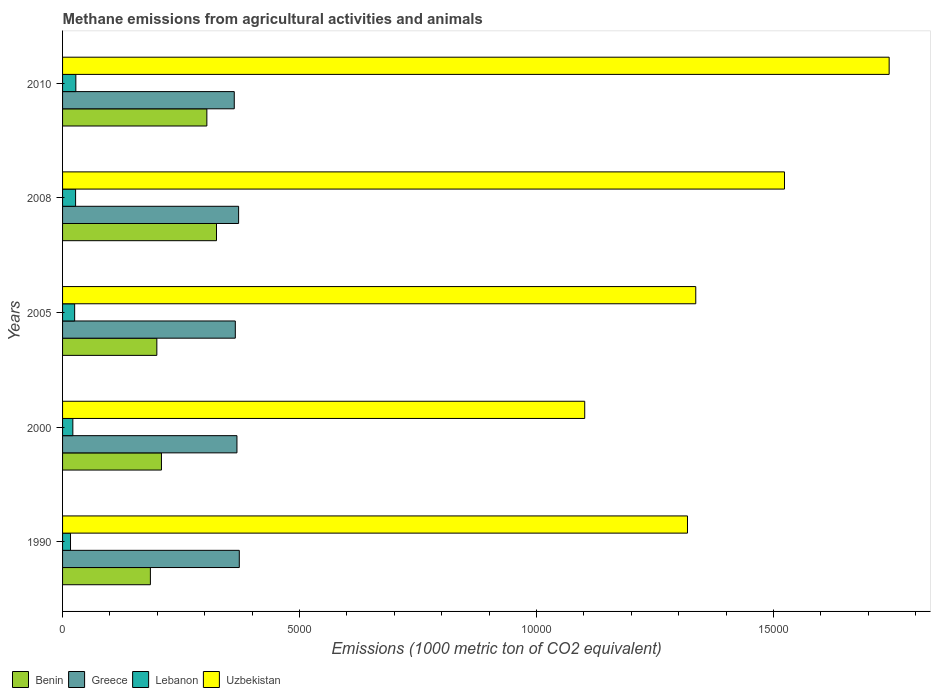How many groups of bars are there?
Give a very brief answer. 5. Are the number of bars per tick equal to the number of legend labels?
Your response must be concise. Yes. What is the label of the 2nd group of bars from the top?
Offer a terse response. 2008. What is the amount of methane emitted in Lebanon in 2000?
Make the answer very short. 216.7. Across all years, what is the maximum amount of methane emitted in Greece?
Your response must be concise. 3728.5. Across all years, what is the minimum amount of methane emitted in Lebanon?
Offer a terse response. 167.6. In which year was the amount of methane emitted in Uzbekistan maximum?
Ensure brevity in your answer.  2010. In which year was the amount of methane emitted in Uzbekistan minimum?
Your answer should be very brief. 2000. What is the total amount of methane emitted in Uzbekistan in the graph?
Your answer should be very brief. 7.02e+04. What is the difference between the amount of methane emitted in Benin in 2005 and that in 2008?
Your answer should be compact. -1258.4. What is the difference between the amount of methane emitted in Uzbekistan in 1990 and the amount of methane emitted in Greece in 2005?
Keep it short and to the point. 9539.8. What is the average amount of methane emitted in Benin per year?
Make the answer very short. 2444.08. In the year 2010, what is the difference between the amount of methane emitted in Greece and amount of methane emitted in Lebanon?
Provide a succinct answer. 3342.4. What is the ratio of the amount of methane emitted in Lebanon in 2008 to that in 2010?
Provide a short and direct response. 0.98. Is the difference between the amount of methane emitted in Greece in 1990 and 2010 greater than the difference between the amount of methane emitted in Lebanon in 1990 and 2010?
Your answer should be very brief. Yes. What is the difference between the highest and the second highest amount of methane emitted in Benin?
Your response must be concise. 203.3. What is the difference between the highest and the lowest amount of methane emitted in Benin?
Offer a very short reply. 1394.6. In how many years, is the amount of methane emitted in Lebanon greater than the average amount of methane emitted in Lebanon taken over all years?
Offer a terse response. 3. Is the sum of the amount of methane emitted in Benin in 2005 and 2010 greater than the maximum amount of methane emitted in Uzbekistan across all years?
Give a very brief answer. No. What does the 1st bar from the bottom in 2008 represents?
Provide a succinct answer. Benin. How many bars are there?
Ensure brevity in your answer.  20. Are all the bars in the graph horizontal?
Provide a short and direct response. Yes. How many years are there in the graph?
Offer a terse response. 5. What is the difference between two consecutive major ticks on the X-axis?
Offer a very short reply. 5000. Are the values on the major ticks of X-axis written in scientific E-notation?
Make the answer very short. No. Does the graph contain any zero values?
Your response must be concise. No. Where does the legend appear in the graph?
Offer a terse response. Bottom left. How many legend labels are there?
Offer a terse response. 4. What is the title of the graph?
Offer a terse response. Methane emissions from agricultural activities and animals. Does "Paraguay" appear as one of the legend labels in the graph?
Your answer should be very brief. No. What is the label or title of the X-axis?
Ensure brevity in your answer.  Emissions (1000 metric ton of CO2 equivalent). What is the label or title of the Y-axis?
Provide a short and direct response. Years. What is the Emissions (1000 metric ton of CO2 equivalent) in Benin in 1990?
Give a very brief answer. 1853. What is the Emissions (1000 metric ton of CO2 equivalent) in Greece in 1990?
Give a very brief answer. 3728.5. What is the Emissions (1000 metric ton of CO2 equivalent) in Lebanon in 1990?
Ensure brevity in your answer.  167.6. What is the Emissions (1000 metric ton of CO2 equivalent) in Uzbekistan in 1990?
Give a very brief answer. 1.32e+04. What is the Emissions (1000 metric ton of CO2 equivalent) of Benin in 2000?
Offer a very short reply. 2086.3. What is the Emissions (1000 metric ton of CO2 equivalent) of Greece in 2000?
Ensure brevity in your answer.  3679.3. What is the Emissions (1000 metric ton of CO2 equivalent) in Lebanon in 2000?
Offer a very short reply. 216.7. What is the Emissions (1000 metric ton of CO2 equivalent) in Uzbekistan in 2000?
Provide a short and direct response. 1.10e+04. What is the Emissions (1000 metric ton of CO2 equivalent) of Benin in 2005?
Offer a terse response. 1989.2. What is the Emissions (1000 metric ton of CO2 equivalent) in Greece in 2005?
Offer a terse response. 3644.6. What is the Emissions (1000 metric ton of CO2 equivalent) in Lebanon in 2005?
Your answer should be very brief. 255.2. What is the Emissions (1000 metric ton of CO2 equivalent) of Uzbekistan in 2005?
Provide a succinct answer. 1.34e+04. What is the Emissions (1000 metric ton of CO2 equivalent) of Benin in 2008?
Keep it short and to the point. 3247.6. What is the Emissions (1000 metric ton of CO2 equivalent) in Greece in 2008?
Make the answer very short. 3714.1. What is the Emissions (1000 metric ton of CO2 equivalent) in Lebanon in 2008?
Offer a very short reply. 275. What is the Emissions (1000 metric ton of CO2 equivalent) in Uzbekistan in 2008?
Keep it short and to the point. 1.52e+04. What is the Emissions (1000 metric ton of CO2 equivalent) in Benin in 2010?
Make the answer very short. 3044.3. What is the Emissions (1000 metric ton of CO2 equivalent) of Greece in 2010?
Give a very brief answer. 3622.4. What is the Emissions (1000 metric ton of CO2 equivalent) of Lebanon in 2010?
Provide a succinct answer. 280. What is the Emissions (1000 metric ton of CO2 equivalent) of Uzbekistan in 2010?
Your answer should be compact. 1.74e+04. Across all years, what is the maximum Emissions (1000 metric ton of CO2 equivalent) of Benin?
Your answer should be very brief. 3247.6. Across all years, what is the maximum Emissions (1000 metric ton of CO2 equivalent) of Greece?
Give a very brief answer. 3728.5. Across all years, what is the maximum Emissions (1000 metric ton of CO2 equivalent) in Lebanon?
Provide a short and direct response. 280. Across all years, what is the maximum Emissions (1000 metric ton of CO2 equivalent) of Uzbekistan?
Your response must be concise. 1.74e+04. Across all years, what is the minimum Emissions (1000 metric ton of CO2 equivalent) in Benin?
Your answer should be compact. 1853. Across all years, what is the minimum Emissions (1000 metric ton of CO2 equivalent) of Greece?
Provide a short and direct response. 3622.4. Across all years, what is the minimum Emissions (1000 metric ton of CO2 equivalent) in Lebanon?
Keep it short and to the point. 167.6. Across all years, what is the minimum Emissions (1000 metric ton of CO2 equivalent) in Uzbekistan?
Ensure brevity in your answer.  1.10e+04. What is the total Emissions (1000 metric ton of CO2 equivalent) in Benin in the graph?
Give a very brief answer. 1.22e+04. What is the total Emissions (1000 metric ton of CO2 equivalent) in Greece in the graph?
Offer a very short reply. 1.84e+04. What is the total Emissions (1000 metric ton of CO2 equivalent) of Lebanon in the graph?
Provide a short and direct response. 1194.5. What is the total Emissions (1000 metric ton of CO2 equivalent) in Uzbekistan in the graph?
Your answer should be very brief. 7.02e+04. What is the difference between the Emissions (1000 metric ton of CO2 equivalent) of Benin in 1990 and that in 2000?
Provide a succinct answer. -233.3. What is the difference between the Emissions (1000 metric ton of CO2 equivalent) in Greece in 1990 and that in 2000?
Give a very brief answer. 49.2. What is the difference between the Emissions (1000 metric ton of CO2 equivalent) of Lebanon in 1990 and that in 2000?
Offer a very short reply. -49.1. What is the difference between the Emissions (1000 metric ton of CO2 equivalent) of Uzbekistan in 1990 and that in 2000?
Make the answer very short. 2168. What is the difference between the Emissions (1000 metric ton of CO2 equivalent) in Benin in 1990 and that in 2005?
Make the answer very short. -136.2. What is the difference between the Emissions (1000 metric ton of CO2 equivalent) of Greece in 1990 and that in 2005?
Offer a very short reply. 83.9. What is the difference between the Emissions (1000 metric ton of CO2 equivalent) of Lebanon in 1990 and that in 2005?
Give a very brief answer. -87.6. What is the difference between the Emissions (1000 metric ton of CO2 equivalent) in Uzbekistan in 1990 and that in 2005?
Offer a very short reply. -174.6. What is the difference between the Emissions (1000 metric ton of CO2 equivalent) of Benin in 1990 and that in 2008?
Your answer should be compact. -1394.6. What is the difference between the Emissions (1000 metric ton of CO2 equivalent) in Lebanon in 1990 and that in 2008?
Make the answer very short. -107.4. What is the difference between the Emissions (1000 metric ton of CO2 equivalent) of Uzbekistan in 1990 and that in 2008?
Your answer should be compact. -2046.5. What is the difference between the Emissions (1000 metric ton of CO2 equivalent) of Benin in 1990 and that in 2010?
Offer a very short reply. -1191.3. What is the difference between the Emissions (1000 metric ton of CO2 equivalent) of Greece in 1990 and that in 2010?
Provide a succinct answer. 106.1. What is the difference between the Emissions (1000 metric ton of CO2 equivalent) in Lebanon in 1990 and that in 2010?
Offer a very short reply. -112.4. What is the difference between the Emissions (1000 metric ton of CO2 equivalent) in Uzbekistan in 1990 and that in 2010?
Keep it short and to the point. -4255. What is the difference between the Emissions (1000 metric ton of CO2 equivalent) in Benin in 2000 and that in 2005?
Your answer should be very brief. 97.1. What is the difference between the Emissions (1000 metric ton of CO2 equivalent) in Greece in 2000 and that in 2005?
Your answer should be compact. 34.7. What is the difference between the Emissions (1000 metric ton of CO2 equivalent) in Lebanon in 2000 and that in 2005?
Give a very brief answer. -38.5. What is the difference between the Emissions (1000 metric ton of CO2 equivalent) of Uzbekistan in 2000 and that in 2005?
Offer a very short reply. -2342.6. What is the difference between the Emissions (1000 metric ton of CO2 equivalent) in Benin in 2000 and that in 2008?
Give a very brief answer. -1161.3. What is the difference between the Emissions (1000 metric ton of CO2 equivalent) in Greece in 2000 and that in 2008?
Offer a very short reply. -34.8. What is the difference between the Emissions (1000 metric ton of CO2 equivalent) in Lebanon in 2000 and that in 2008?
Your answer should be very brief. -58.3. What is the difference between the Emissions (1000 metric ton of CO2 equivalent) in Uzbekistan in 2000 and that in 2008?
Provide a succinct answer. -4214.5. What is the difference between the Emissions (1000 metric ton of CO2 equivalent) of Benin in 2000 and that in 2010?
Make the answer very short. -958. What is the difference between the Emissions (1000 metric ton of CO2 equivalent) in Greece in 2000 and that in 2010?
Ensure brevity in your answer.  56.9. What is the difference between the Emissions (1000 metric ton of CO2 equivalent) in Lebanon in 2000 and that in 2010?
Make the answer very short. -63.3. What is the difference between the Emissions (1000 metric ton of CO2 equivalent) of Uzbekistan in 2000 and that in 2010?
Your response must be concise. -6423. What is the difference between the Emissions (1000 metric ton of CO2 equivalent) in Benin in 2005 and that in 2008?
Your answer should be compact. -1258.4. What is the difference between the Emissions (1000 metric ton of CO2 equivalent) of Greece in 2005 and that in 2008?
Provide a succinct answer. -69.5. What is the difference between the Emissions (1000 metric ton of CO2 equivalent) in Lebanon in 2005 and that in 2008?
Keep it short and to the point. -19.8. What is the difference between the Emissions (1000 metric ton of CO2 equivalent) of Uzbekistan in 2005 and that in 2008?
Provide a short and direct response. -1871.9. What is the difference between the Emissions (1000 metric ton of CO2 equivalent) in Benin in 2005 and that in 2010?
Give a very brief answer. -1055.1. What is the difference between the Emissions (1000 metric ton of CO2 equivalent) in Greece in 2005 and that in 2010?
Offer a very short reply. 22.2. What is the difference between the Emissions (1000 metric ton of CO2 equivalent) in Lebanon in 2005 and that in 2010?
Your answer should be compact. -24.8. What is the difference between the Emissions (1000 metric ton of CO2 equivalent) in Uzbekistan in 2005 and that in 2010?
Keep it short and to the point. -4080.4. What is the difference between the Emissions (1000 metric ton of CO2 equivalent) of Benin in 2008 and that in 2010?
Offer a very short reply. 203.3. What is the difference between the Emissions (1000 metric ton of CO2 equivalent) of Greece in 2008 and that in 2010?
Provide a succinct answer. 91.7. What is the difference between the Emissions (1000 metric ton of CO2 equivalent) in Uzbekistan in 2008 and that in 2010?
Keep it short and to the point. -2208.5. What is the difference between the Emissions (1000 metric ton of CO2 equivalent) of Benin in 1990 and the Emissions (1000 metric ton of CO2 equivalent) of Greece in 2000?
Ensure brevity in your answer.  -1826.3. What is the difference between the Emissions (1000 metric ton of CO2 equivalent) in Benin in 1990 and the Emissions (1000 metric ton of CO2 equivalent) in Lebanon in 2000?
Your answer should be compact. 1636.3. What is the difference between the Emissions (1000 metric ton of CO2 equivalent) of Benin in 1990 and the Emissions (1000 metric ton of CO2 equivalent) of Uzbekistan in 2000?
Provide a succinct answer. -9163.4. What is the difference between the Emissions (1000 metric ton of CO2 equivalent) in Greece in 1990 and the Emissions (1000 metric ton of CO2 equivalent) in Lebanon in 2000?
Give a very brief answer. 3511.8. What is the difference between the Emissions (1000 metric ton of CO2 equivalent) in Greece in 1990 and the Emissions (1000 metric ton of CO2 equivalent) in Uzbekistan in 2000?
Your answer should be very brief. -7287.9. What is the difference between the Emissions (1000 metric ton of CO2 equivalent) in Lebanon in 1990 and the Emissions (1000 metric ton of CO2 equivalent) in Uzbekistan in 2000?
Provide a succinct answer. -1.08e+04. What is the difference between the Emissions (1000 metric ton of CO2 equivalent) in Benin in 1990 and the Emissions (1000 metric ton of CO2 equivalent) in Greece in 2005?
Your answer should be very brief. -1791.6. What is the difference between the Emissions (1000 metric ton of CO2 equivalent) in Benin in 1990 and the Emissions (1000 metric ton of CO2 equivalent) in Lebanon in 2005?
Your answer should be very brief. 1597.8. What is the difference between the Emissions (1000 metric ton of CO2 equivalent) of Benin in 1990 and the Emissions (1000 metric ton of CO2 equivalent) of Uzbekistan in 2005?
Your answer should be very brief. -1.15e+04. What is the difference between the Emissions (1000 metric ton of CO2 equivalent) in Greece in 1990 and the Emissions (1000 metric ton of CO2 equivalent) in Lebanon in 2005?
Give a very brief answer. 3473.3. What is the difference between the Emissions (1000 metric ton of CO2 equivalent) in Greece in 1990 and the Emissions (1000 metric ton of CO2 equivalent) in Uzbekistan in 2005?
Provide a short and direct response. -9630.5. What is the difference between the Emissions (1000 metric ton of CO2 equivalent) in Lebanon in 1990 and the Emissions (1000 metric ton of CO2 equivalent) in Uzbekistan in 2005?
Offer a terse response. -1.32e+04. What is the difference between the Emissions (1000 metric ton of CO2 equivalent) of Benin in 1990 and the Emissions (1000 metric ton of CO2 equivalent) of Greece in 2008?
Keep it short and to the point. -1861.1. What is the difference between the Emissions (1000 metric ton of CO2 equivalent) in Benin in 1990 and the Emissions (1000 metric ton of CO2 equivalent) in Lebanon in 2008?
Make the answer very short. 1578. What is the difference between the Emissions (1000 metric ton of CO2 equivalent) in Benin in 1990 and the Emissions (1000 metric ton of CO2 equivalent) in Uzbekistan in 2008?
Make the answer very short. -1.34e+04. What is the difference between the Emissions (1000 metric ton of CO2 equivalent) of Greece in 1990 and the Emissions (1000 metric ton of CO2 equivalent) of Lebanon in 2008?
Offer a very short reply. 3453.5. What is the difference between the Emissions (1000 metric ton of CO2 equivalent) in Greece in 1990 and the Emissions (1000 metric ton of CO2 equivalent) in Uzbekistan in 2008?
Provide a succinct answer. -1.15e+04. What is the difference between the Emissions (1000 metric ton of CO2 equivalent) of Lebanon in 1990 and the Emissions (1000 metric ton of CO2 equivalent) of Uzbekistan in 2008?
Keep it short and to the point. -1.51e+04. What is the difference between the Emissions (1000 metric ton of CO2 equivalent) of Benin in 1990 and the Emissions (1000 metric ton of CO2 equivalent) of Greece in 2010?
Keep it short and to the point. -1769.4. What is the difference between the Emissions (1000 metric ton of CO2 equivalent) in Benin in 1990 and the Emissions (1000 metric ton of CO2 equivalent) in Lebanon in 2010?
Offer a very short reply. 1573. What is the difference between the Emissions (1000 metric ton of CO2 equivalent) of Benin in 1990 and the Emissions (1000 metric ton of CO2 equivalent) of Uzbekistan in 2010?
Your response must be concise. -1.56e+04. What is the difference between the Emissions (1000 metric ton of CO2 equivalent) in Greece in 1990 and the Emissions (1000 metric ton of CO2 equivalent) in Lebanon in 2010?
Offer a very short reply. 3448.5. What is the difference between the Emissions (1000 metric ton of CO2 equivalent) of Greece in 1990 and the Emissions (1000 metric ton of CO2 equivalent) of Uzbekistan in 2010?
Your answer should be compact. -1.37e+04. What is the difference between the Emissions (1000 metric ton of CO2 equivalent) in Lebanon in 1990 and the Emissions (1000 metric ton of CO2 equivalent) in Uzbekistan in 2010?
Give a very brief answer. -1.73e+04. What is the difference between the Emissions (1000 metric ton of CO2 equivalent) of Benin in 2000 and the Emissions (1000 metric ton of CO2 equivalent) of Greece in 2005?
Your answer should be compact. -1558.3. What is the difference between the Emissions (1000 metric ton of CO2 equivalent) of Benin in 2000 and the Emissions (1000 metric ton of CO2 equivalent) of Lebanon in 2005?
Provide a short and direct response. 1831.1. What is the difference between the Emissions (1000 metric ton of CO2 equivalent) in Benin in 2000 and the Emissions (1000 metric ton of CO2 equivalent) in Uzbekistan in 2005?
Give a very brief answer. -1.13e+04. What is the difference between the Emissions (1000 metric ton of CO2 equivalent) of Greece in 2000 and the Emissions (1000 metric ton of CO2 equivalent) of Lebanon in 2005?
Keep it short and to the point. 3424.1. What is the difference between the Emissions (1000 metric ton of CO2 equivalent) in Greece in 2000 and the Emissions (1000 metric ton of CO2 equivalent) in Uzbekistan in 2005?
Ensure brevity in your answer.  -9679.7. What is the difference between the Emissions (1000 metric ton of CO2 equivalent) of Lebanon in 2000 and the Emissions (1000 metric ton of CO2 equivalent) of Uzbekistan in 2005?
Give a very brief answer. -1.31e+04. What is the difference between the Emissions (1000 metric ton of CO2 equivalent) in Benin in 2000 and the Emissions (1000 metric ton of CO2 equivalent) in Greece in 2008?
Your answer should be very brief. -1627.8. What is the difference between the Emissions (1000 metric ton of CO2 equivalent) of Benin in 2000 and the Emissions (1000 metric ton of CO2 equivalent) of Lebanon in 2008?
Your response must be concise. 1811.3. What is the difference between the Emissions (1000 metric ton of CO2 equivalent) in Benin in 2000 and the Emissions (1000 metric ton of CO2 equivalent) in Uzbekistan in 2008?
Offer a very short reply. -1.31e+04. What is the difference between the Emissions (1000 metric ton of CO2 equivalent) in Greece in 2000 and the Emissions (1000 metric ton of CO2 equivalent) in Lebanon in 2008?
Keep it short and to the point. 3404.3. What is the difference between the Emissions (1000 metric ton of CO2 equivalent) in Greece in 2000 and the Emissions (1000 metric ton of CO2 equivalent) in Uzbekistan in 2008?
Give a very brief answer. -1.16e+04. What is the difference between the Emissions (1000 metric ton of CO2 equivalent) of Lebanon in 2000 and the Emissions (1000 metric ton of CO2 equivalent) of Uzbekistan in 2008?
Your answer should be very brief. -1.50e+04. What is the difference between the Emissions (1000 metric ton of CO2 equivalent) in Benin in 2000 and the Emissions (1000 metric ton of CO2 equivalent) in Greece in 2010?
Keep it short and to the point. -1536.1. What is the difference between the Emissions (1000 metric ton of CO2 equivalent) of Benin in 2000 and the Emissions (1000 metric ton of CO2 equivalent) of Lebanon in 2010?
Give a very brief answer. 1806.3. What is the difference between the Emissions (1000 metric ton of CO2 equivalent) in Benin in 2000 and the Emissions (1000 metric ton of CO2 equivalent) in Uzbekistan in 2010?
Provide a short and direct response. -1.54e+04. What is the difference between the Emissions (1000 metric ton of CO2 equivalent) of Greece in 2000 and the Emissions (1000 metric ton of CO2 equivalent) of Lebanon in 2010?
Offer a terse response. 3399.3. What is the difference between the Emissions (1000 metric ton of CO2 equivalent) in Greece in 2000 and the Emissions (1000 metric ton of CO2 equivalent) in Uzbekistan in 2010?
Your response must be concise. -1.38e+04. What is the difference between the Emissions (1000 metric ton of CO2 equivalent) of Lebanon in 2000 and the Emissions (1000 metric ton of CO2 equivalent) of Uzbekistan in 2010?
Your response must be concise. -1.72e+04. What is the difference between the Emissions (1000 metric ton of CO2 equivalent) of Benin in 2005 and the Emissions (1000 metric ton of CO2 equivalent) of Greece in 2008?
Ensure brevity in your answer.  -1724.9. What is the difference between the Emissions (1000 metric ton of CO2 equivalent) in Benin in 2005 and the Emissions (1000 metric ton of CO2 equivalent) in Lebanon in 2008?
Give a very brief answer. 1714.2. What is the difference between the Emissions (1000 metric ton of CO2 equivalent) of Benin in 2005 and the Emissions (1000 metric ton of CO2 equivalent) of Uzbekistan in 2008?
Make the answer very short. -1.32e+04. What is the difference between the Emissions (1000 metric ton of CO2 equivalent) of Greece in 2005 and the Emissions (1000 metric ton of CO2 equivalent) of Lebanon in 2008?
Provide a short and direct response. 3369.6. What is the difference between the Emissions (1000 metric ton of CO2 equivalent) in Greece in 2005 and the Emissions (1000 metric ton of CO2 equivalent) in Uzbekistan in 2008?
Provide a short and direct response. -1.16e+04. What is the difference between the Emissions (1000 metric ton of CO2 equivalent) in Lebanon in 2005 and the Emissions (1000 metric ton of CO2 equivalent) in Uzbekistan in 2008?
Keep it short and to the point. -1.50e+04. What is the difference between the Emissions (1000 metric ton of CO2 equivalent) in Benin in 2005 and the Emissions (1000 metric ton of CO2 equivalent) in Greece in 2010?
Make the answer very short. -1633.2. What is the difference between the Emissions (1000 metric ton of CO2 equivalent) in Benin in 2005 and the Emissions (1000 metric ton of CO2 equivalent) in Lebanon in 2010?
Provide a short and direct response. 1709.2. What is the difference between the Emissions (1000 metric ton of CO2 equivalent) in Benin in 2005 and the Emissions (1000 metric ton of CO2 equivalent) in Uzbekistan in 2010?
Offer a terse response. -1.55e+04. What is the difference between the Emissions (1000 metric ton of CO2 equivalent) in Greece in 2005 and the Emissions (1000 metric ton of CO2 equivalent) in Lebanon in 2010?
Provide a succinct answer. 3364.6. What is the difference between the Emissions (1000 metric ton of CO2 equivalent) in Greece in 2005 and the Emissions (1000 metric ton of CO2 equivalent) in Uzbekistan in 2010?
Provide a short and direct response. -1.38e+04. What is the difference between the Emissions (1000 metric ton of CO2 equivalent) in Lebanon in 2005 and the Emissions (1000 metric ton of CO2 equivalent) in Uzbekistan in 2010?
Your answer should be very brief. -1.72e+04. What is the difference between the Emissions (1000 metric ton of CO2 equivalent) of Benin in 2008 and the Emissions (1000 metric ton of CO2 equivalent) of Greece in 2010?
Ensure brevity in your answer.  -374.8. What is the difference between the Emissions (1000 metric ton of CO2 equivalent) of Benin in 2008 and the Emissions (1000 metric ton of CO2 equivalent) of Lebanon in 2010?
Offer a terse response. 2967.6. What is the difference between the Emissions (1000 metric ton of CO2 equivalent) in Benin in 2008 and the Emissions (1000 metric ton of CO2 equivalent) in Uzbekistan in 2010?
Provide a succinct answer. -1.42e+04. What is the difference between the Emissions (1000 metric ton of CO2 equivalent) of Greece in 2008 and the Emissions (1000 metric ton of CO2 equivalent) of Lebanon in 2010?
Your response must be concise. 3434.1. What is the difference between the Emissions (1000 metric ton of CO2 equivalent) in Greece in 2008 and the Emissions (1000 metric ton of CO2 equivalent) in Uzbekistan in 2010?
Your response must be concise. -1.37e+04. What is the difference between the Emissions (1000 metric ton of CO2 equivalent) in Lebanon in 2008 and the Emissions (1000 metric ton of CO2 equivalent) in Uzbekistan in 2010?
Provide a succinct answer. -1.72e+04. What is the average Emissions (1000 metric ton of CO2 equivalent) in Benin per year?
Provide a short and direct response. 2444.08. What is the average Emissions (1000 metric ton of CO2 equivalent) in Greece per year?
Provide a succinct answer. 3677.78. What is the average Emissions (1000 metric ton of CO2 equivalent) of Lebanon per year?
Give a very brief answer. 238.9. What is the average Emissions (1000 metric ton of CO2 equivalent) in Uzbekistan per year?
Offer a terse response. 1.40e+04. In the year 1990, what is the difference between the Emissions (1000 metric ton of CO2 equivalent) in Benin and Emissions (1000 metric ton of CO2 equivalent) in Greece?
Your answer should be very brief. -1875.5. In the year 1990, what is the difference between the Emissions (1000 metric ton of CO2 equivalent) in Benin and Emissions (1000 metric ton of CO2 equivalent) in Lebanon?
Your answer should be very brief. 1685.4. In the year 1990, what is the difference between the Emissions (1000 metric ton of CO2 equivalent) in Benin and Emissions (1000 metric ton of CO2 equivalent) in Uzbekistan?
Ensure brevity in your answer.  -1.13e+04. In the year 1990, what is the difference between the Emissions (1000 metric ton of CO2 equivalent) in Greece and Emissions (1000 metric ton of CO2 equivalent) in Lebanon?
Provide a short and direct response. 3560.9. In the year 1990, what is the difference between the Emissions (1000 metric ton of CO2 equivalent) of Greece and Emissions (1000 metric ton of CO2 equivalent) of Uzbekistan?
Offer a terse response. -9455.9. In the year 1990, what is the difference between the Emissions (1000 metric ton of CO2 equivalent) in Lebanon and Emissions (1000 metric ton of CO2 equivalent) in Uzbekistan?
Your answer should be compact. -1.30e+04. In the year 2000, what is the difference between the Emissions (1000 metric ton of CO2 equivalent) of Benin and Emissions (1000 metric ton of CO2 equivalent) of Greece?
Offer a terse response. -1593. In the year 2000, what is the difference between the Emissions (1000 metric ton of CO2 equivalent) in Benin and Emissions (1000 metric ton of CO2 equivalent) in Lebanon?
Give a very brief answer. 1869.6. In the year 2000, what is the difference between the Emissions (1000 metric ton of CO2 equivalent) of Benin and Emissions (1000 metric ton of CO2 equivalent) of Uzbekistan?
Your answer should be very brief. -8930.1. In the year 2000, what is the difference between the Emissions (1000 metric ton of CO2 equivalent) of Greece and Emissions (1000 metric ton of CO2 equivalent) of Lebanon?
Your answer should be very brief. 3462.6. In the year 2000, what is the difference between the Emissions (1000 metric ton of CO2 equivalent) of Greece and Emissions (1000 metric ton of CO2 equivalent) of Uzbekistan?
Provide a short and direct response. -7337.1. In the year 2000, what is the difference between the Emissions (1000 metric ton of CO2 equivalent) of Lebanon and Emissions (1000 metric ton of CO2 equivalent) of Uzbekistan?
Your answer should be very brief. -1.08e+04. In the year 2005, what is the difference between the Emissions (1000 metric ton of CO2 equivalent) in Benin and Emissions (1000 metric ton of CO2 equivalent) in Greece?
Your response must be concise. -1655.4. In the year 2005, what is the difference between the Emissions (1000 metric ton of CO2 equivalent) of Benin and Emissions (1000 metric ton of CO2 equivalent) of Lebanon?
Offer a very short reply. 1734. In the year 2005, what is the difference between the Emissions (1000 metric ton of CO2 equivalent) of Benin and Emissions (1000 metric ton of CO2 equivalent) of Uzbekistan?
Your answer should be compact. -1.14e+04. In the year 2005, what is the difference between the Emissions (1000 metric ton of CO2 equivalent) in Greece and Emissions (1000 metric ton of CO2 equivalent) in Lebanon?
Keep it short and to the point. 3389.4. In the year 2005, what is the difference between the Emissions (1000 metric ton of CO2 equivalent) of Greece and Emissions (1000 metric ton of CO2 equivalent) of Uzbekistan?
Your answer should be very brief. -9714.4. In the year 2005, what is the difference between the Emissions (1000 metric ton of CO2 equivalent) of Lebanon and Emissions (1000 metric ton of CO2 equivalent) of Uzbekistan?
Offer a terse response. -1.31e+04. In the year 2008, what is the difference between the Emissions (1000 metric ton of CO2 equivalent) of Benin and Emissions (1000 metric ton of CO2 equivalent) of Greece?
Offer a very short reply. -466.5. In the year 2008, what is the difference between the Emissions (1000 metric ton of CO2 equivalent) in Benin and Emissions (1000 metric ton of CO2 equivalent) in Lebanon?
Your answer should be very brief. 2972.6. In the year 2008, what is the difference between the Emissions (1000 metric ton of CO2 equivalent) of Benin and Emissions (1000 metric ton of CO2 equivalent) of Uzbekistan?
Offer a very short reply. -1.20e+04. In the year 2008, what is the difference between the Emissions (1000 metric ton of CO2 equivalent) in Greece and Emissions (1000 metric ton of CO2 equivalent) in Lebanon?
Give a very brief answer. 3439.1. In the year 2008, what is the difference between the Emissions (1000 metric ton of CO2 equivalent) in Greece and Emissions (1000 metric ton of CO2 equivalent) in Uzbekistan?
Provide a short and direct response. -1.15e+04. In the year 2008, what is the difference between the Emissions (1000 metric ton of CO2 equivalent) in Lebanon and Emissions (1000 metric ton of CO2 equivalent) in Uzbekistan?
Your response must be concise. -1.50e+04. In the year 2010, what is the difference between the Emissions (1000 metric ton of CO2 equivalent) in Benin and Emissions (1000 metric ton of CO2 equivalent) in Greece?
Give a very brief answer. -578.1. In the year 2010, what is the difference between the Emissions (1000 metric ton of CO2 equivalent) of Benin and Emissions (1000 metric ton of CO2 equivalent) of Lebanon?
Give a very brief answer. 2764.3. In the year 2010, what is the difference between the Emissions (1000 metric ton of CO2 equivalent) of Benin and Emissions (1000 metric ton of CO2 equivalent) of Uzbekistan?
Keep it short and to the point. -1.44e+04. In the year 2010, what is the difference between the Emissions (1000 metric ton of CO2 equivalent) of Greece and Emissions (1000 metric ton of CO2 equivalent) of Lebanon?
Offer a terse response. 3342.4. In the year 2010, what is the difference between the Emissions (1000 metric ton of CO2 equivalent) in Greece and Emissions (1000 metric ton of CO2 equivalent) in Uzbekistan?
Your response must be concise. -1.38e+04. In the year 2010, what is the difference between the Emissions (1000 metric ton of CO2 equivalent) of Lebanon and Emissions (1000 metric ton of CO2 equivalent) of Uzbekistan?
Your response must be concise. -1.72e+04. What is the ratio of the Emissions (1000 metric ton of CO2 equivalent) of Benin in 1990 to that in 2000?
Make the answer very short. 0.89. What is the ratio of the Emissions (1000 metric ton of CO2 equivalent) in Greece in 1990 to that in 2000?
Your response must be concise. 1.01. What is the ratio of the Emissions (1000 metric ton of CO2 equivalent) of Lebanon in 1990 to that in 2000?
Offer a very short reply. 0.77. What is the ratio of the Emissions (1000 metric ton of CO2 equivalent) in Uzbekistan in 1990 to that in 2000?
Keep it short and to the point. 1.2. What is the ratio of the Emissions (1000 metric ton of CO2 equivalent) in Benin in 1990 to that in 2005?
Offer a terse response. 0.93. What is the ratio of the Emissions (1000 metric ton of CO2 equivalent) of Lebanon in 1990 to that in 2005?
Your response must be concise. 0.66. What is the ratio of the Emissions (1000 metric ton of CO2 equivalent) in Uzbekistan in 1990 to that in 2005?
Offer a very short reply. 0.99. What is the ratio of the Emissions (1000 metric ton of CO2 equivalent) of Benin in 1990 to that in 2008?
Your answer should be compact. 0.57. What is the ratio of the Emissions (1000 metric ton of CO2 equivalent) of Greece in 1990 to that in 2008?
Ensure brevity in your answer.  1. What is the ratio of the Emissions (1000 metric ton of CO2 equivalent) in Lebanon in 1990 to that in 2008?
Your response must be concise. 0.61. What is the ratio of the Emissions (1000 metric ton of CO2 equivalent) of Uzbekistan in 1990 to that in 2008?
Your response must be concise. 0.87. What is the ratio of the Emissions (1000 metric ton of CO2 equivalent) in Benin in 1990 to that in 2010?
Offer a terse response. 0.61. What is the ratio of the Emissions (1000 metric ton of CO2 equivalent) of Greece in 1990 to that in 2010?
Ensure brevity in your answer.  1.03. What is the ratio of the Emissions (1000 metric ton of CO2 equivalent) of Lebanon in 1990 to that in 2010?
Make the answer very short. 0.6. What is the ratio of the Emissions (1000 metric ton of CO2 equivalent) in Uzbekistan in 1990 to that in 2010?
Make the answer very short. 0.76. What is the ratio of the Emissions (1000 metric ton of CO2 equivalent) of Benin in 2000 to that in 2005?
Make the answer very short. 1.05. What is the ratio of the Emissions (1000 metric ton of CO2 equivalent) in Greece in 2000 to that in 2005?
Provide a short and direct response. 1.01. What is the ratio of the Emissions (1000 metric ton of CO2 equivalent) in Lebanon in 2000 to that in 2005?
Provide a succinct answer. 0.85. What is the ratio of the Emissions (1000 metric ton of CO2 equivalent) in Uzbekistan in 2000 to that in 2005?
Offer a terse response. 0.82. What is the ratio of the Emissions (1000 metric ton of CO2 equivalent) in Benin in 2000 to that in 2008?
Keep it short and to the point. 0.64. What is the ratio of the Emissions (1000 metric ton of CO2 equivalent) in Greece in 2000 to that in 2008?
Provide a succinct answer. 0.99. What is the ratio of the Emissions (1000 metric ton of CO2 equivalent) in Lebanon in 2000 to that in 2008?
Ensure brevity in your answer.  0.79. What is the ratio of the Emissions (1000 metric ton of CO2 equivalent) in Uzbekistan in 2000 to that in 2008?
Provide a short and direct response. 0.72. What is the ratio of the Emissions (1000 metric ton of CO2 equivalent) in Benin in 2000 to that in 2010?
Give a very brief answer. 0.69. What is the ratio of the Emissions (1000 metric ton of CO2 equivalent) in Greece in 2000 to that in 2010?
Offer a very short reply. 1.02. What is the ratio of the Emissions (1000 metric ton of CO2 equivalent) in Lebanon in 2000 to that in 2010?
Offer a terse response. 0.77. What is the ratio of the Emissions (1000 metric ton of CO2 equivalent) in Uzbekistan in 2000 to that in 2010?
Make the answer very short. 0.63. What is the ratio of the Emissions (1000 metric ton of CO2 equivalent) of Benin in 2005 to that in 2008?
Make the answer very short. 0.61. What is the ratio of the Emissions (1000 metric ton of CO2 equivalent) of Greece in 2005 to that in 2008?
Make the answer very short. 0.98. What is the ratio of the Emissions (1000 metric ton of CO2 equivalent) of Lebanon in 2005 to that in 2008?
Give a very brief answer. 0.93. What is the ratio of the Emissions (1000 metric ton of CO2 equivalent) in Uzbekistan in 2005 to that in 2008?
Your answer should be compact. 0.88. What is the ratio of the Emissions (1000 metric ton of CO2 equivalent) of Benin in 2005 to that in 2010?
Make the answer very short. 0.65. What is the ratio of the Emissions (1000 metric ton of CO2 equivalent) of Lebanon in 2005 to that in 2010?
Your response must be concise. 0.91. What is the ratio of the Emissions (1000 metric ton of CO2 equivalent) in Uzbekistan in 2005 to that in 2010?
Provide a succinct answer. 0.77. What is the ratio of the Emissions (1000 metric ton of CO2 equivalent) of Benin in 2008 to that in 2010?
Provide a succinct answer. 1.07. What is the ratio of the Emissions (1000 metric ton of CO2 equivalent) in Greece in 2008 to that in 2010?
Provide a short and direct response. 1.03. What is the ratio of the Emissions (1000 metric ton of CO2 equivalent) in Lebanon in 2008 to that in 2010?
Your response must be concise. 0.98. What is the ratio of the Emissions (1000 metric ton of CO2 equivalent) of Uzbekistan in 2008 to that in 2010?
Ensure brevity in your answer.  0.87. What is the difference between the highest and the second highest Emissions (1000 metric ton of CO2 equivalent) in Benin?
Offer a terse response. 203.3. What is the difference between the highest and the second highest Emissions (1000 metric ton of CO2 equivalent) in Lebanon?
Your answer should be compact. 5. What is the difference between the highest and the second highest Emissions (1000 metric ton of CO2 equivalent) in Uzbekistan?
Your answer should be compact. 2208.5. What is the difference between the highest and the lowest Emissions (1000 metric ton of CO2 equivalent) in Benin?
Your answer should be compact. 1394.6. What is the difference between the highest and the lowest Emissions (1000 metric ton of CO2 equivalent) in Greece?
Offer a terse response. 106.1. What is the difference between the highest and the lowest Emissions (1000 metric ton of CO2 equivalent) in Lebanon?
Give a very brief answer. 112.4. What is the difference between the highest and the lowest Emissions (1000 metric ton of CO2 equivalent) of Uzbekistan?
Your answer should be very brief. 6423. 